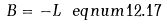Convert formula to latex. <formula><loc_0><loc_0><loc_500><loc_500>B = - L \ e q n u m { 1 2 . 1 7 }</formula> 